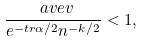<formula> <loc_0><loc_0><loc_500><loc_500>\frac { \ a v e v } { e ^ { - \L t r { \alpha } / 2 } n ^ { - k / 2 } } < 1 ,</formula> 